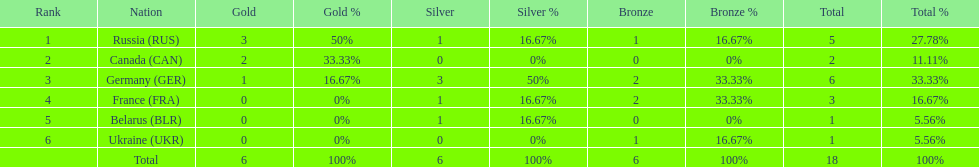Name the country that had the same number of bronze medals as russia. Ukraine. 